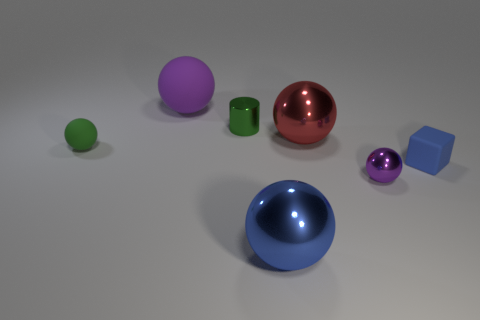Is there any other thing that is the same shape as the purple matte object?
Provide a short and direct response. Yes. How many things are tiny objects or big gray metal spheres?
Ensure brevity in your answer.  4. Do the purple ball to the left of the green shiny object and the blue shiny object have the same size?
Your response must be concise. Yes. How many other objects are the same size as the purple shiny sphere?
Offer a terse response. 3. Are any blue blocks visible?
Provide a short and direct response. Yes. There is a blue thing behind the large metal object that is in front of the small purple metallic sphere; what size is it?
Provide a short and direct response. Small. Do the tiny metal thing that is behind the red metal object and the rubber ball that is in front of the red shiny ball have the same color?
Offer a very short reply. Yes. The thing that is to the left of the tiny green metal cylinder and behind the red thing is what color?
Provide a succinct answer. Purple. What number of other things are there of the same shape as the red shiny thing?
Provide a succinct answer. 4. What color is the rubber object that is the same size as the blue block?
Your response must be concise. Green. 